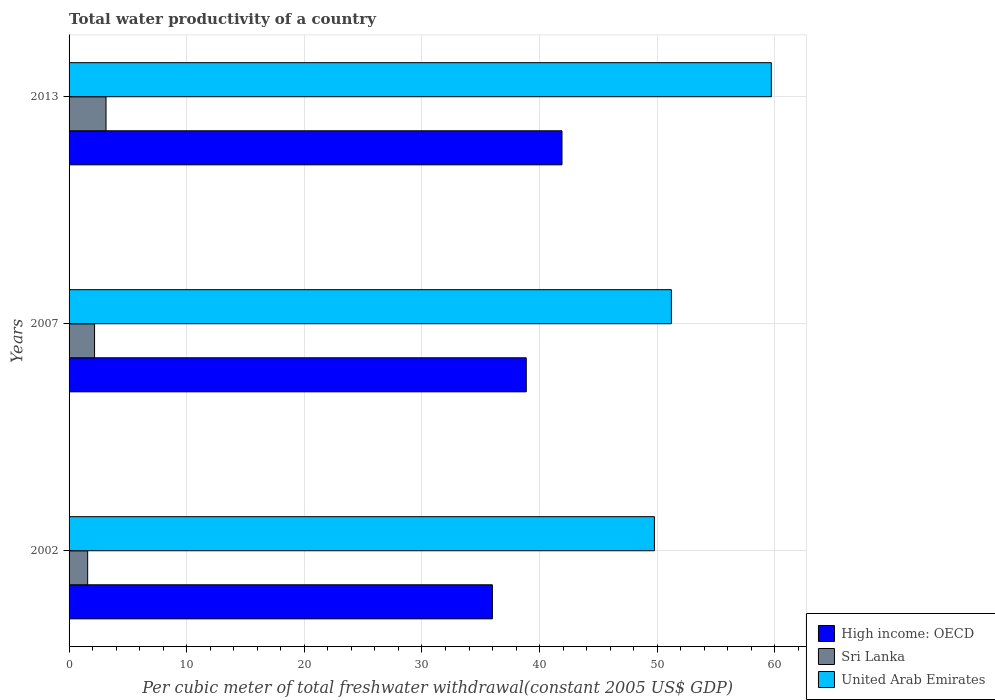How many groups of bars are there?
Provide a succinct answer. 3. Are the number of bars per tick equal to the number of legend labels?
Your answer should be very brief. Yes. Are the number of bars on each tick of the Y-axis equal?
Your answer should be very brief. Yes. How many bars are there on the 3rd tick from the top?
Your response must be concise. 3. How many bars are there on the 3rd tick from the bottom?
Give a very brief answer. 3. What is the label of the 2nd group of bars from the top?
Your answer should be very brief. 2007. What is the total water productivity in High income: OECD in 2002?
Offer a terse response. 35.98. Across all years, what is the maximum total water productivity in United Arab Emirates?
Give a very brief answer. 59.7. Across all years, what is the minimum total water productivity in United Arab Emirates?
Give a very brief answer. 49.76. In which year was the total water productivity in Sri Lanka minimum?
Give a very brief answer. 2002. What is the total total water productivity in United Arab Emirates in the graph?
Provide a succinct answer. 160.66. What is the difference between the total water productivity in High income: OECD in 2002 and that in 2013?
Keep it short and to the point. -5.92. What is the difference between the total water productivity in High income: OECD in 2013 and the total water productivity in Sri Lanka in 2002?
Offer a terse response. 40.32. What is the average total water productivity in Sri Lanka per year?
Your answer should be compact. 2.3. In the year 2007, what is the difference between the total water productivity in United Arab Emirates and total water productivity in High income: OECD?
Offer a very short reply. 12.34. What is the ratio of the total water productivity in Sri Lanka in 2007 to that in 2013?
Offer a terse response. 0.69. What is the difference between the highest and the second highest total water productivity in Sri Lanka?
Your response must be concise. 0.97. What is the difference between the highest and the lowest total water productivity in High income: OECD?
Ensure brevity in your answer.  5.92. In how many years, is the total water productivity in High income: OECD greater than the average total water productivity in High income: OECD taken over all years?
Your answer should be very brief. 1. What does the 1st bar from the top in 2007 represents?
Keep it short and to the point. United Arab Emirates. What does the 3rd bar from the bottom in 2002 represents?
Offer a terse response. United Arab Emirates. Is it the case that in every year, the sum of the total water productivity in Sri Lanka and total water productivity in United Arab Emirates is greater than the total water productivity in High income: OECD?
Your answer should be compact. Yes. What is the difference between two consecutive major ticks on the X-axis?
Your answer should be very brief. 10. Does the graph contain any zero values?
Provide a succinct answer. No. How many legend labels are there?
Your answer should be very brief. 3. What is the title of the graph?
Offer a very short reply. Total water productivity of a country. What is the label or title of the X-axis?
Offer a terse response. Per cubic meter of total freshwater withdrawal(constant 2005 US$ GDP). What is the label or title of the Y-axis?
Your response must be concise. Years. What is the Per cubic meter of total freshwater withdrawal(constant 2005 US$ GDP) in High income: OECD in 2002?
Provide a succinct answer. 35.98. What is the Per cubic meter of total freshwater withdrawal(constant 2005 US$ GDP) in Sri Lanka in 2002?
Provide a short and direct response. 1.58. What is the Per cubic meter of total freshwater withdrawal(constant 2005 US$ GDP) in United Arab Emirates in 2002?
Make the answer very short. 49.76. What is the Per cubic meter of total freshwater withdrawal(constant 2005 US$ GDP) of High income: OECD in 2007?
Your response must be concise. 38.87. What is the Per cubic meter of total freshwater withdrawal(constant 2005 US$ GDP) in Sri Lanka in 2007?
Keep it short and to the point. 2.17. What is the Per cubic meter of total freshwater withdrawal(constant 2005 US$ GDP) in United Arab Emirates in 2007?
Ensure brevity in your answer.  51.2. What is the Per cubic meter of total freshwater withdrawal(constant 2005 US$ GDP) of High income: OECD in 2013?
Your answer should be compact. 41.9. What is the Per cubic meter of total freshwater withdrawal(constant 2005 US$ GDP) of Sri Lanka in 2013?
Your answer should be compact. 3.14. What is the Per cubic meter of total freshwater withdrawal(constant 2005 US$ GDP) in United Arab Emirates in 2013?
Make the answer very short. 59.7. Across all years, what is the maximum Per cubic meter of total freshwater withdrawal(constant 2005 US$ GDP) of High income: OECD?
Ensure brevity in your answer.  41.9. Across all years, what is the maximum Per cubic meter of total freshwater withdrawal(constant 2005 US$ GDP) of Sri Lanka?
Provide a short and direct response. 3.14. Across all years, what is the maximum Per cubic meter of total freshwater withdrawal(constant 2005 US$ GDP) of United Arab Emirates?
Offer a very short reply. 59.7. Across all years, what is the minimum Per cubic meter of total freshwater withdrawal(constant 2005 US$ GDP) in High income: OECD?
Your answer should be compact. 35.98. Across all years, what is the minimum Per cubic meter of total freshwater withdrawal(constant 2005 US$ GDP) in Sri Lanka?
Your answer should be compact. 1.58. Across all years, what is the minimum Per cubic meter of total freshwater withdrawal(constant 2005 US$ GDP) in United Arab Emirates?
Give a very brief answer. 49.76. What is the total Per cubic meter of total freshwater withdrawal(constant 2005 US$ GDP) in High income: OECD in the graph?
Make the answer very short. 116.75. What is the total Per cubic meter of total freshwater withdrawal(constant 2005 US$ GDP) in Sri Lanka in the graph?
Your response must be concise. 6.89. What is the total Per cubic meter of total freshwater withdrawal(constant 2005 US$ GDP) of United Arab Emirates in the graph?
Your response must be concise. 160.66. What is the difference between the Per cubic meter of total freshwater withdrawal(constant 2005 US$ GDP) in High income: OECD in 2002 and that in 2007?
Your answer should be very brief. -2.88. What is the difference between the Per cubic meter of total freshwater withdrawal(constant 2005 US$ GDP) in Sri Lanka in 2002 and that in 2007?
Your response must be concise. -0.59. What is the difference between the Per cubic meter of total freshwater withdrawal(constant 2005 US$ GDP) in United Arab Emirates in 2002 and that in 2007?
Your response must be concise. -1.44. What is the difference between the Per cubic meter of total freshwater withdrawal(constant 2005 US$ GDP) in High income: OECD in 2002 and that in 2013?
Provide a succinct answer. -5.92. What is the difference between the Per cubic meter of total freshwater withdrawal(constant 2005 US$ GDP) of Sri Lanka in 2002 and that in 2013?
Give a very brief answer. -1.56. What is the difference between the Per cubic meter of total freshwater withdrawal(constant 2005 US$ GDP) in United Arab Emirates in 2002 and that in 2013?
Offer a very short reply. -9.94. What is the difference between the Per cubic meter of total freshwater withdrawal(constant 2005 US$ GDP) of High income: OECD in 2007 and that in 2013?
Provide a short and direct response. -3.04. What is the difference between the Per cubic meter of total freshwater withdrawal(constant 2005 US$ GDP) of Sri Lanka in 2007 and that in 2013?
Offer a very short reply. -0.97. What is the difference between the Per cubic meter of total freshwater withdrawal(constant 2005 US$ GDP) in United Arab Emirates in 2007 and that in 2013?
Provide a short and direct response. -8.5. What is the difference between the Per cubic meter of total freshwater withdrawal(constant 2005 US$ GDP) of High income: OECD in 2002 and the Per cubic meter of total freshwater withdrawal(constant 2005 US$ GDP) of Sri Lanka in 2007?
Provide a short and direct response. 33.82. What is the difference between the Per cubic meter of total freshwater withdrawal(constant 2005 US$ GDP) in High income: OECD in 2002 and the Per cubic meter of total freshwater withdrawal(constant 2005 US$ GDP) in United Arab Emirates in 2007?
Your response must be concise. -15.22. What is the difference between the Per cubic meter of total freshwater withdrawal(constant 2005 US$ GDP) in Sri Lanka in 2002 and the Per cubic meter of total freshwater withdrawal(constant 2005 US$ GDP) in United Arab Emirates in 2007?
Keep it short and to the point. -49.62. What is the difference between the Per cubic meter of total freshwater withdrawal(constant 2005 US$ GDP) of High income: OECD in 2002 and the Per cubic meter of total freshwater withdrawal(constant 2005 US$ GDP) of Sri Lanka in 2013?
Keep it short and to the point. 32.84. What is the difference between the Per cubic meter of total freshwater withdrawal(constant 2005 US$ GDP) in High income: OECD in 2002 and the Per cubic meter of total freshwater withdrawal(constant 2005 US$ GDP) in United Arab Emirates in 2013?
Your response must be concise. -23.71. What is the difference between the Per cubic meter of total freshwater withdrawal(constant 2005 US$ GDP) of Sri Lanka in 2002 and the Per cubic meter of total freshwater withdrawal(constant 2005 US$ GDP) of United Arab Emirates in 2013?
Provide a succinct answer. -58.12. What is the difference between the Per cubic meter of total freshwater withdrawal(constant 2005 US$ GDP) in High income: OECD in 2007 and the Per cubic meter of total freshwater withdrawal(constant 2005 US$ GDP) in Sri Lanka in 2013?
Offer a very short reply. 35.72. What is the difference between the Per cubic meter of total freshwater withdrawal(constant 2005 US$ GDP) of High income: OECD in 2007 and the Per cubic meter of total freshwater withdrawal(constant 2005 US$ GDP) of United Arab Emirates in 2013?
Offer a terse response. -20.83. What is the difference between the Per cubic meter of total freshwater withdrawal(constant 2005 US$ GDP) in Sri Lanka in 2007 and the Per cubic meter of total freshwater withdrawal(constant 2005 US$ GDP) in United Arab Emirates in 2013?
Your answer should be very brief. -57.53. What is the average Per cubic meter of total freshwater withdrawal(constant 2005 US$ GDP) of High income: OECD per year?
Offer a terse response. 38.92. What is the average Per cubic meter of total freshwater withdrawal(constant 2005 US$ GDP) in Sri Lanka per year?
Your response must be concise. 2.3. What is the average Per cubic meter of total freshwater withdrawal(constant 2005 US$ GDP) of United Arab Emirates per year?
Provide a short and direct response. 53.55. In the year 2002, what is the difference between the Per cubic meter of total freshwater withdrawal(constant 2005 US$ GDP) in High income: OECD and Per cubic meter of total freshwater withdrawal(constant 2005 US$ GDP) in Sri Lanka?
Provide a short and direct response. 34.4. In the year 2002, what is the difference between the Per cubic meter of total freshwater withdrawal(constant 2005 US$ GDP) of High income: OECD and Per cubic meter of total freshwater withdrawal(constant 2005 US$ GDP) of United Arab Emirates?
Your answer should be very brief. -13.77. In the year 2002, what is the difference between the Per cubic meter of total freshwater withdrawal(constant 2005 US$ GDP) of Sri Lanka and Per cubic meter of total freshwater withdrawal(constant 2005 US$ GDP) of United Arab Emirates?
Offer a terse response. -48.18. In the year 2007, what is the difference between the Per cubic meter of total freshwater withdrawal(constant 2005 US$ GDP) in High income: OECD and Per cubic meter of total freshwater withdrawal(constant 2005 US$ GDP) in Sri Lanka?
Ensure brevity in your answer.  36.7. In the year 2007, what is the difference between the Per cubic meter of total freshwater withdrawal(constant 2005 US$ GDP) of High income: OECD and Per cubic meter of total freshwater withdrawal(constant 2005 US$ GDP) of United Arab Emirates?
Your answer should be very brief. -12.34. In the year 2007, what is the difference between the Per cubic meter of total freshwater withdrawal(constant 2005 US$ GDP) of Sri Lanka and Per cubic meter of total freshwater withdrawal(constant 2005 US$ GDP) of United Arab Emirates?
Your answer should be very brief. -49.03. In the year 2013, what is the difference between the Per cubic meter of total freshwater withdrawal(constant 2005 US$ GDP) of High income: OECD and Per cubic meter of total freshwater withdrawal(constant 2005 US$ GDP) of Sri Lanka?
Offer a very short reply. 38.76. In the year 2013, what is the difference between the Per cubic meter of total freshwater withdrawal(constant 2005 US$ GDP) of High income: OECD and Per cubic meter of total freshwater withdrawal(constant 2005 US$ GDP) of United Arab Emirates?
Make the answer very short. -17.79. In the year 2013, what is the difference between the Per cubic meter of total freshwater withdrawal(constant 2005 US$ GDP) in Sri Lanka and Per cubic meter of total freshwater withdrawal(constant 2005 US$ GDP) in United Arab Emirates?
Keep it short and to the point. -56.56. What is the ratio of the Per cubic meter of total freshwater withdrawal(constant 2005 US$ GDP) of High income: OECD in 2002 to that in 2007?
Give a very brief answer. 0.93. What is the ratio of the Per cubic meter of total freshwater withdrawal(constant 2005 US$ GDP) in Sri Lanka in 2002 to that in 2007?
Provide a short and direct response. 0.73. What is the ratio of the Per cubic meter of total freshwater withdrawal(constant 2005 US$ GDP) in United Arab Emirates in 2002 to that in 2007?
Your answer should be very brief. 0.97. What is the ratio of the Per cubic meter of total freshwater withdrawal(constant 2005 US$ GDP) of High income: OECD in 2002 to that in 2013?
Offer a terse response. 0.86. What is the ratio of the Per cubic meter of total freshwater withdrawal(constant 2005 US$ GDP) of Sri Lanka in 2002 to that in 2013?
Your response must be concise. 0.5. What is the ratio of the Per cubic meter of total freshwater withdrawal(constant 2005 US$ GDP) of United Arab Emirates in 2002 to that in 2013?
Give a very brief answer. 0.83. What is the ratio of the Per cubic meter of total freshwater withdrawal(constant 2005 US$ GDP) of High income: OECD in 2007 to that in 2013?
Provide a short and direct response. 0.93. What is the ratio of the Per cubic meter of total freshwater withdrawal(constant 2005 US$ GDP) of Sri Lanka in 2007 to that in 2013?
Your answer should be compact. 0.69. What is the ratio of the Per cubic meter of total freshwater withdrawal(constant 2005 US$ GDP) in United Arab Emirates in 2007 to that in 2013?
Keep it short and to the point. 0.86. What is the difference between the highest and the second highest Per cubic meter of total freshwater withdrawal(constant 2005 US$ GDP) in High income: OECD?
Provide a succinct answer. 3.04. What is the difference between the highest and the second highest Per cubic meter of total freshwater withdrawal(constant 2005 US$ GDP) of Sri Lanka?
Your answer should be very brief. 0.97. What is the difference between the highest and the second highest Per cubic meter of total freshwater withdrawal(constant 2005 US$ GDP) in United Arab Emirates?
Provide a succinct answer. 8.5. What is the difference between the highest and the lowest Per cubic meter of total freshwater withdrawal(constant 2005 US$ GDP) of High income: OECD?
Your response must be concise. 5.92. What is the difference between the highest and the lowest Per cubic meter of total freshwater withdrawal(constant 2005 US$ GDP) of Sri Lanka?
Offer a terse response. 1.56. What is the difference between the highest and the lowest Per cubic meter of total freshwater withdrawal(constant 2005 US$ GDP) of United Arab Emirates?
Your answer should be compact. 9.94. 